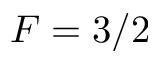Convert formula to latex. <formula><loc_0><loc_0><loc_500><loc_500>F = 3 / 2</formula> 